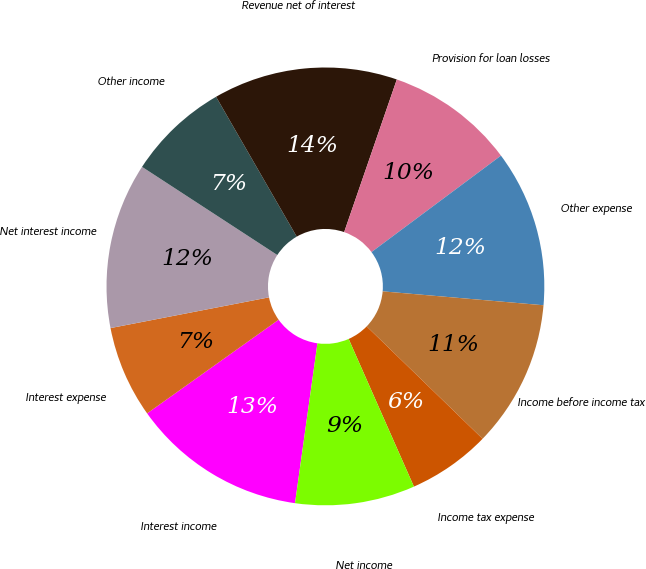Convert chart. <chart><loc_0><loc_0><loc_500><loc_500><pie_chart><fcel>Interest income<fcel>Interest expense<fcel>Net interest income<fcel>Other income<fcel>Revenue net of interest<fcel>Provision for loan losses<fcel>Other expense<fcel>Income before income tax<fcel>Income tax expense<fcel>Net income<nl><fcel>12.93%<fcel>6.8%<fcel>12.24%<fcel>7.48%<fcel>13.61%<fcel>9.52%<fcel>11.56%<fcel>10.88%<fcel>6.12%<fcel>8.84%<nl></chart> 